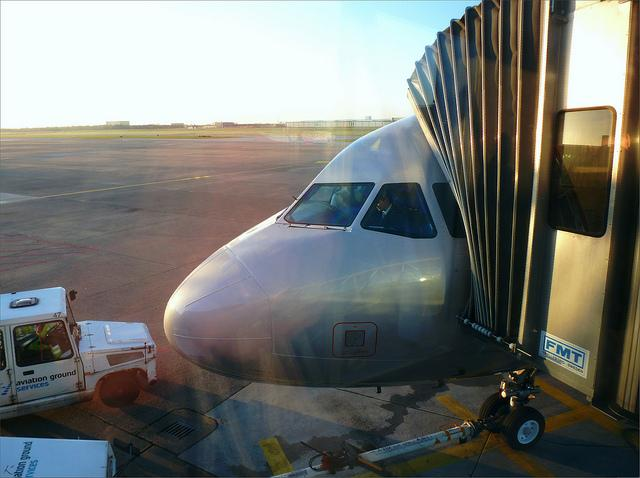What is this part of the plane known as?

Choices:
A) cockpit
B) stern
C) runway
D) first class cockpit 